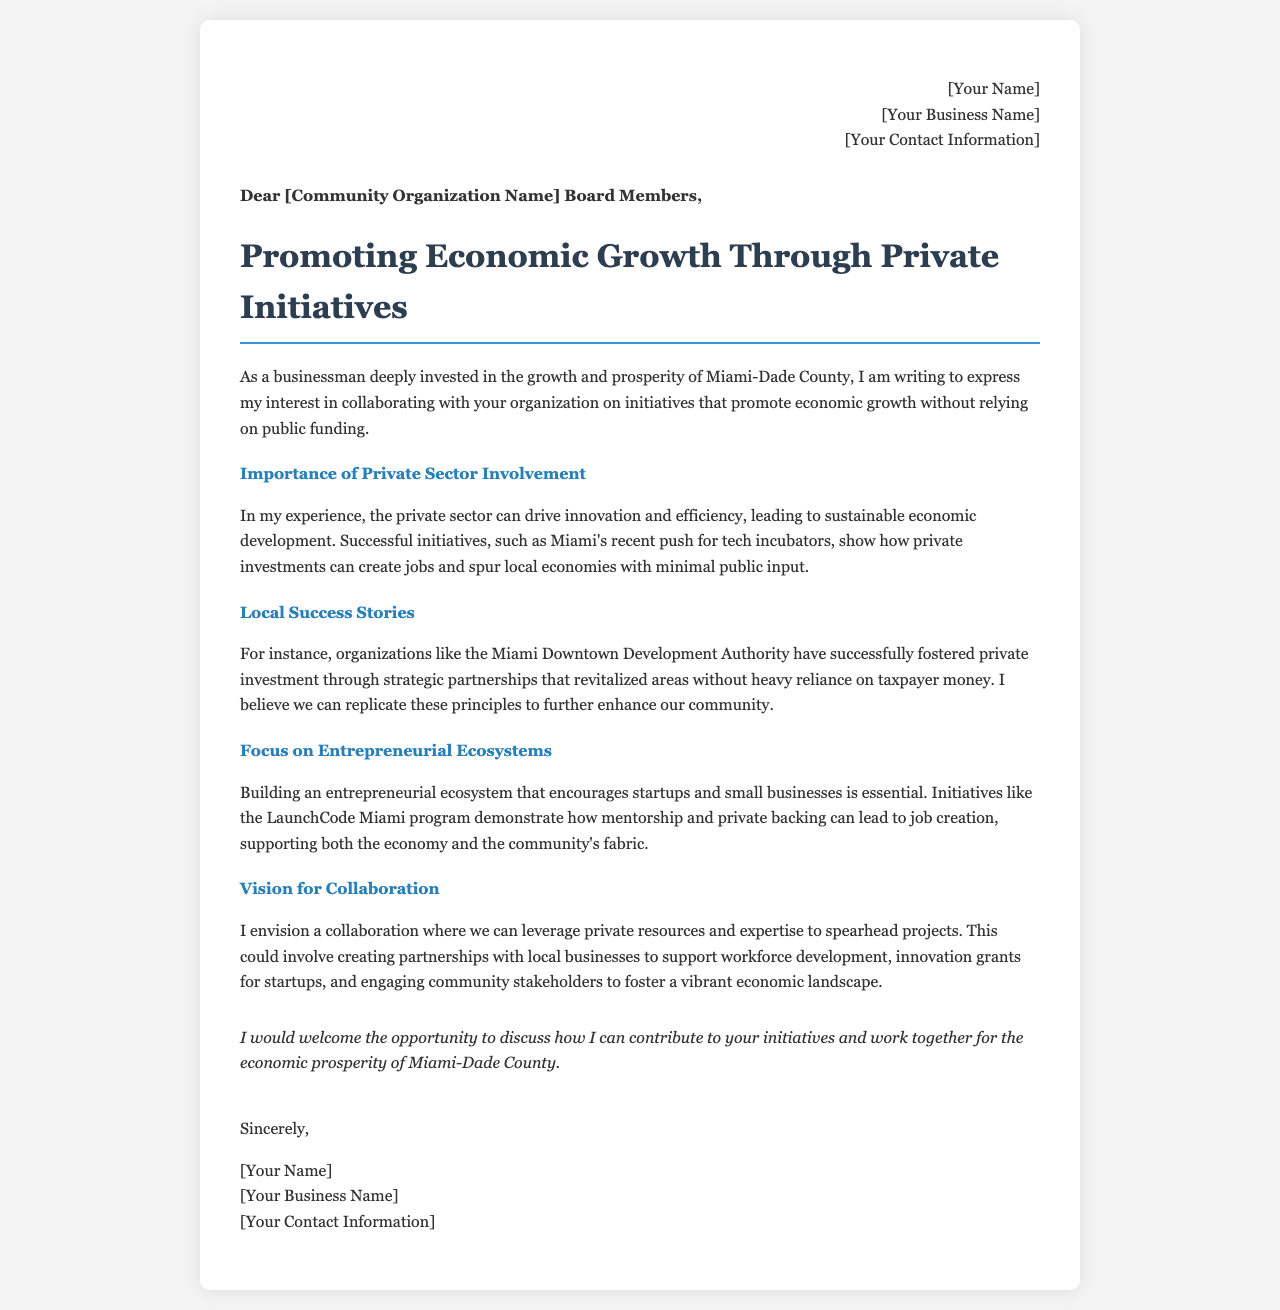What is the purpose of the letter? The purpose of the letter is to express interest in collaborating on initiatives that promote economic growth without relying on public funding.
Answer: To express interest in collaborating Who is the letter addressed to? The letter is addressed to the Board Members of a specific community organization.
Answer: [Community Organization Name] Board Members What is one example of a private initiative mentioned? The letter mentions Miami's recent push for tech incubators as an example of a successful private initiative.
Answer: Tech incubators What type of initiatives does the author propose? The author proposes creating partnerships with local businesses to support workforce development and innovation.
Answer: Partnerships with local businesses What does the author believe the private sector can drive? The author believes the private sector can drive innovation and efficiency for sustainable economic development.
Answer: Innovation and efficiency Which program is cited as a demonstration of mentorship and private backing? The LaunchCode Miami program is cited as an example of mentorship and private backing leading to job creation.
Answer: LaunchCode Miami What does the author envision for collaboration? The author envisions leveraging private resources and expertise to spearhead projects.
Answer: Leveraging private resources and expertise What is the conclusion's sentiment towards collaboration? The conclusion expresses a welcoming attitude towards discussing contributions to initiatives.
Answer: Welcoming What does the author believe about local success stories? The author believes local success stories show how to foster private investment without heavy reliance on taxpayer money.
Answer: Foster private investment without heavy reliance on taxpayer money 